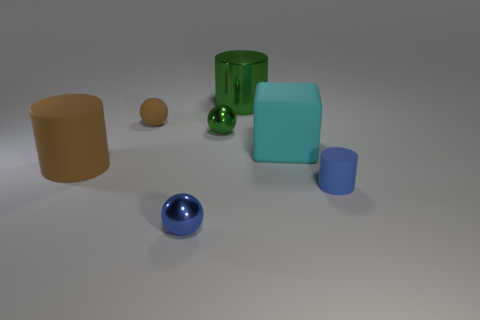Do the big matte block and the rubber object behind the cube have the same color? no 